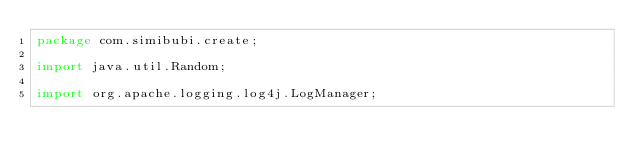<code> <loc_0><loc_0><loc_500><loc_500><_Java_>package com.simibubi.create;

import java.util.Random;

import org.apache.logging.log4j.LogManager;</code> 